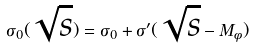<formula> <loc_0><loc_0><loc_500><loc_500>\sigma _ { 0 } ( \sqrt { s } ) = \sigma _ { 0 } + \sigma ^ { \prime } ( \sqrt { s } - M _ { \phi } )</formula> 